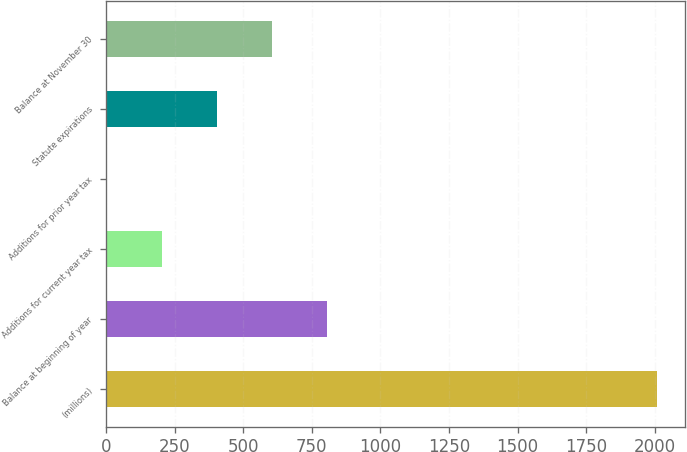<chart> <loc_0><loc_0><loc_500><loc_500><bar_chart><fcel>(millions)<fcel>Balance at beginning of year<fcel>Additions for current year tax<fcel>Additions for prior year tax<fcel>Statute expirations<fcel>Balance at November 30<nl><fcel>2010<fcel>806.04<fcel>204.06<fcel>3.4<fcel>404.72<fcel>605.38<nl></chart> 